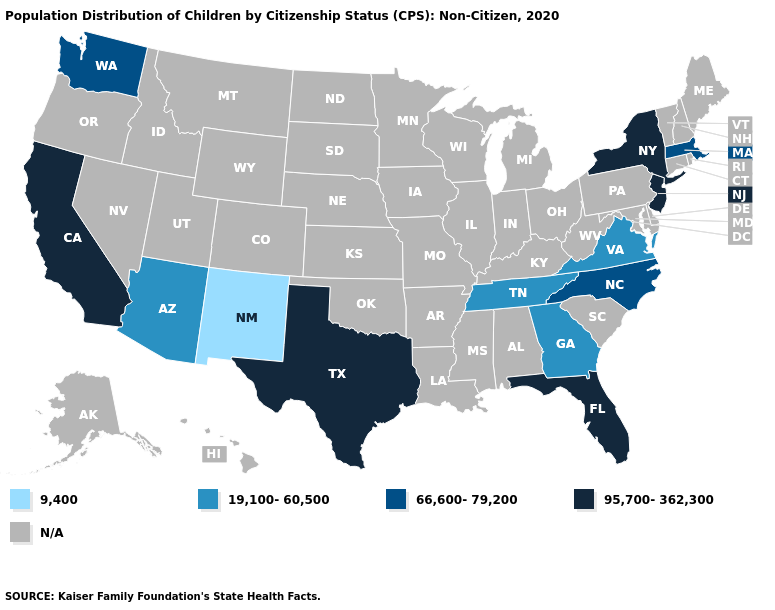Does the map have missing data?
Short answer required. Yes. Does the first symbol in the legend represent the smallest category?
Keep it brief. Yes. Does the first symbol in the legend represent the smallest category?
Concise answer only. Yes. What is the value of Iowa?
Quick response, please. N/A. Which states have the highest value in the USA?
Quick response, please. California, Florida, New Jersey, New York, Texas. What is the lowest value in the USA?
Quick response, please. 9,400. Does Washington have the highest value in the USA?
Give a very brief answer. No. Among the states that border Arkansas , does Texas have the highest value?
Write a very short answer. Yes. Does Massachusetts have the highest value in the Northeast?
Keep it brief. No. Is the legend a continuous bar?
Give a very brief answer. No. What is the value of North Carolina?
Give a very brief answer. 66,600-79,200. What is the value of Alabama?
Give a very brief answer. N/A. Does the first symbol in the legend represent the smallest category?
Concise answer only. Yes. 